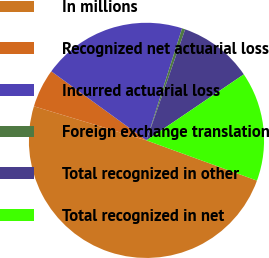<chart> <loc_0><loc_0><loc_500><loc_500><pie_chart><fcel>In millions<fcel>Recognized net actuarial loss<fcel>Incurred actuarial loss<fcel>Foreign exchange translation<fcel>Total recognized in other<fcel>Total recognized in net<nl><fcel>49.12%<fcel>5.31%<fcel>19.91%<fcel>0.44%<fcel>10.18%<fcel>15.04%<nl></chart> 